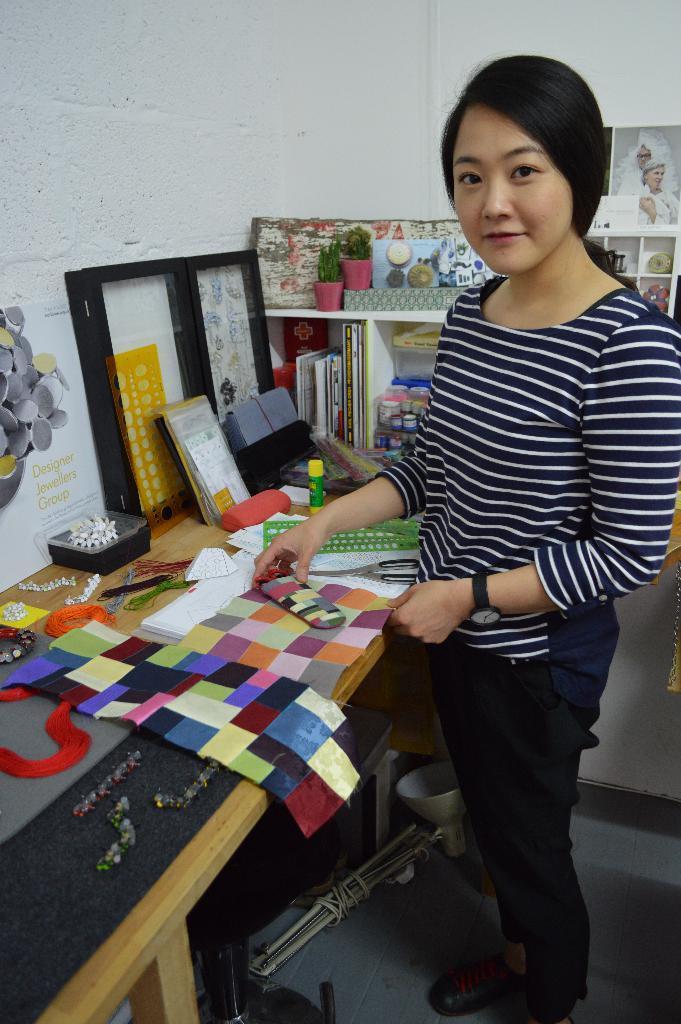Can you describe this image briefly? Woman in this picture wearing blue and white T-shirt is standing near the table and she is holding some paper in her hands and on the table, we can see a colorful cloth, papers, book, plastic box, wires and threads. Beside her, we see rack in which small bottles and books are placed in it and on background, we see a white wall on which photo frame of man and woman is placed on it. 